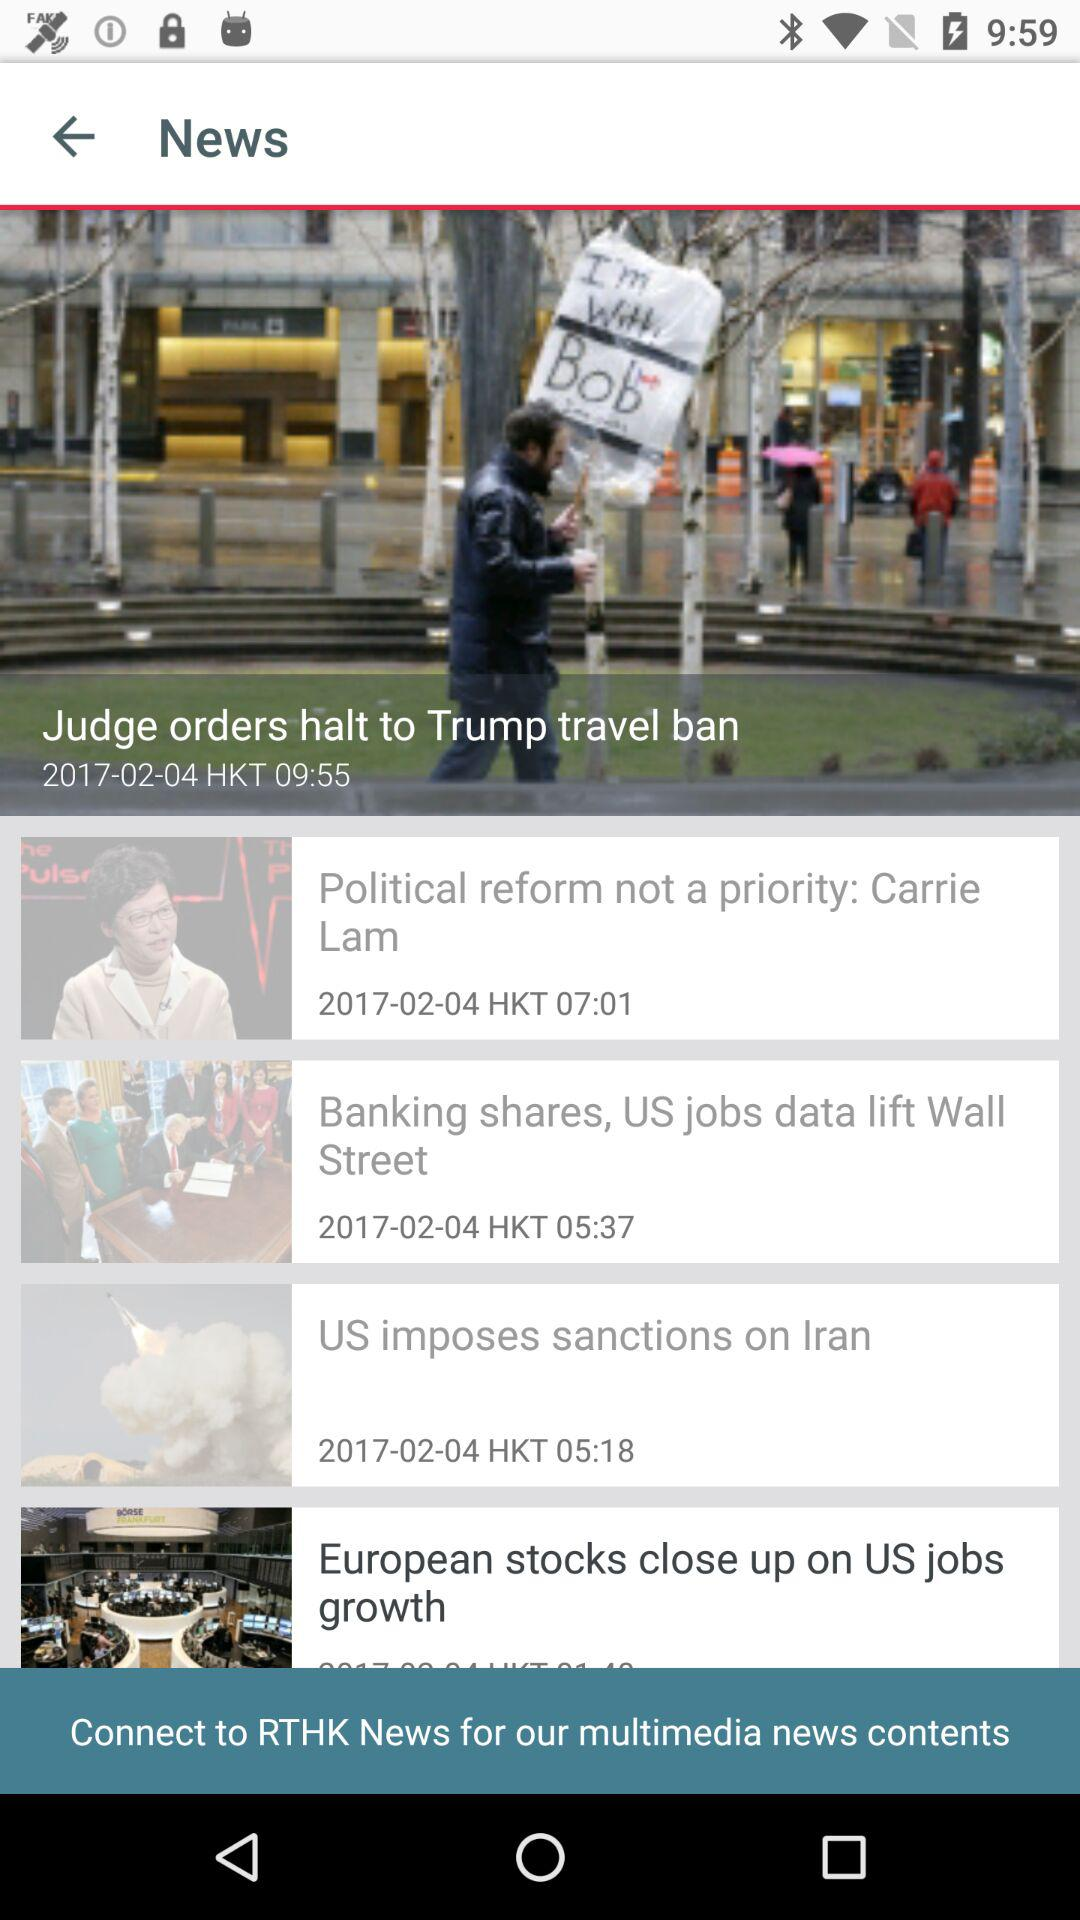At what time was the news "Judge orders halt to Trump travel ban" posted? The news "Judge orders halt to Trump travel ban" was posted at 09:55 HKT. 